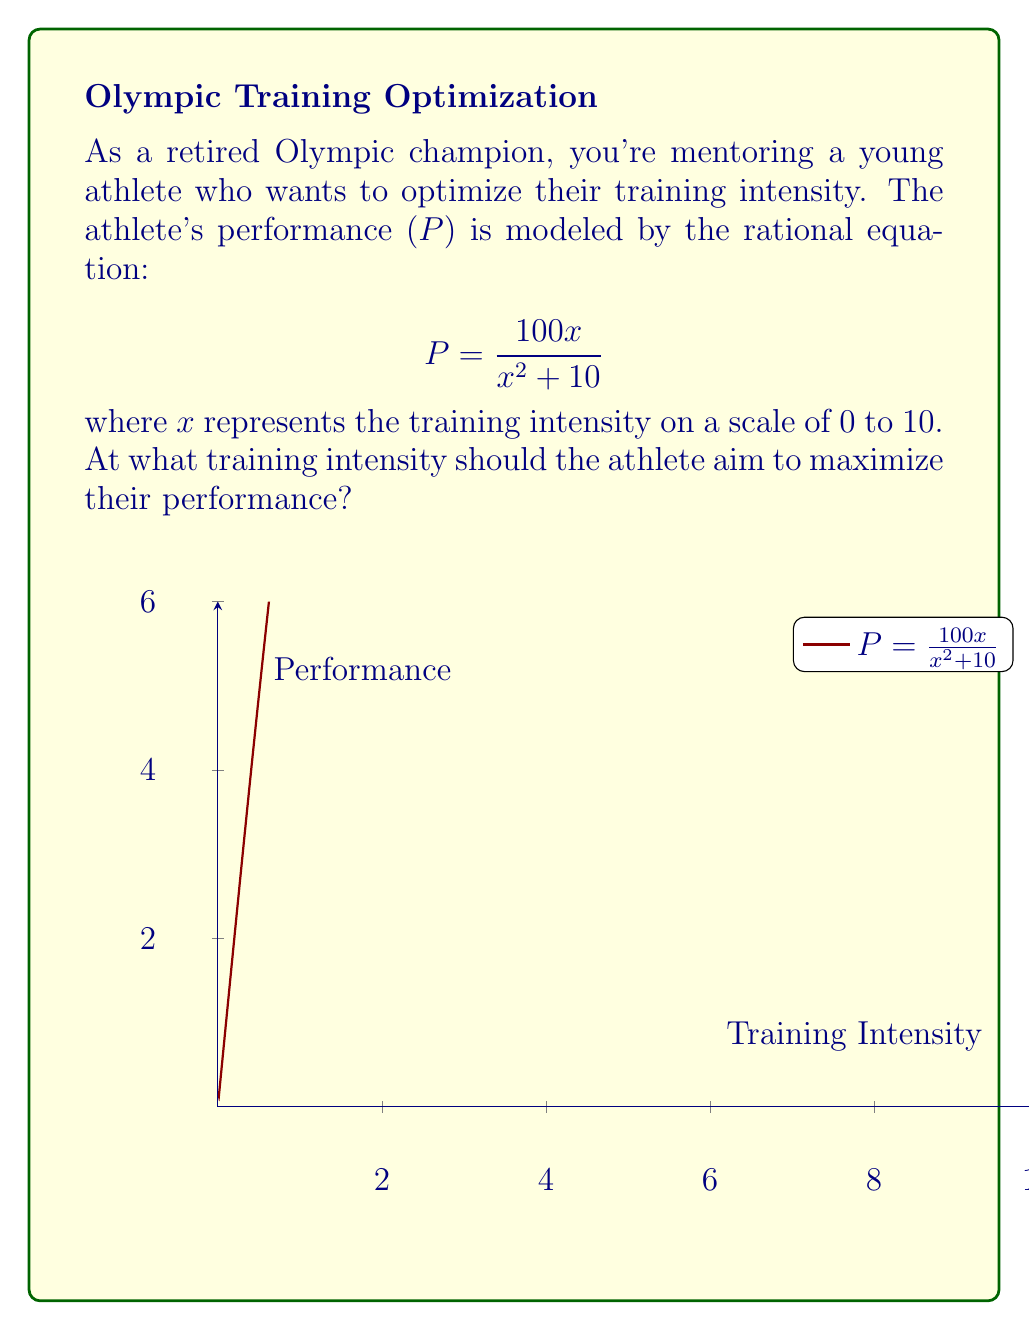What is the answer to this math problem? To find the maximum performance, we need to follow these steps:

1) First, we need to find the derivative of P with respect to x:

   $$\frac{dP}{dx} = \frac{100(x^2+10) - 100x(2x)}{(x^2+10)^2} = \frac{1000 - 100x^2}{(x^2+10)^2}$$

2) To find the maximum, set the derivative equal to zero and solve for x:

   $$\frac{1000 - 100x^2}{(x^2+10)^2} = 0$$

3) The denominator is always positive, so we only need to solve:

   $$1000 - 100x^2 = 0$$

4) Simplify:

   $$10 = x^2$$

5) Take the square root of both sides:

   $$x = \sqrt{10} \approx 3.16$$

6) To confirm this is a maximum (not a minimum), we can check that the second derivative is negative at this point, or observe that the performance decreases for values on either side of $\sqrt{10}$.

Therefore, the athlete should aim for a training intensity of $\sqrt{10}$ (approximately 3.16 on the 0-10 scale) to maximize their performance.
Answer: $\sqrt{10}$ 